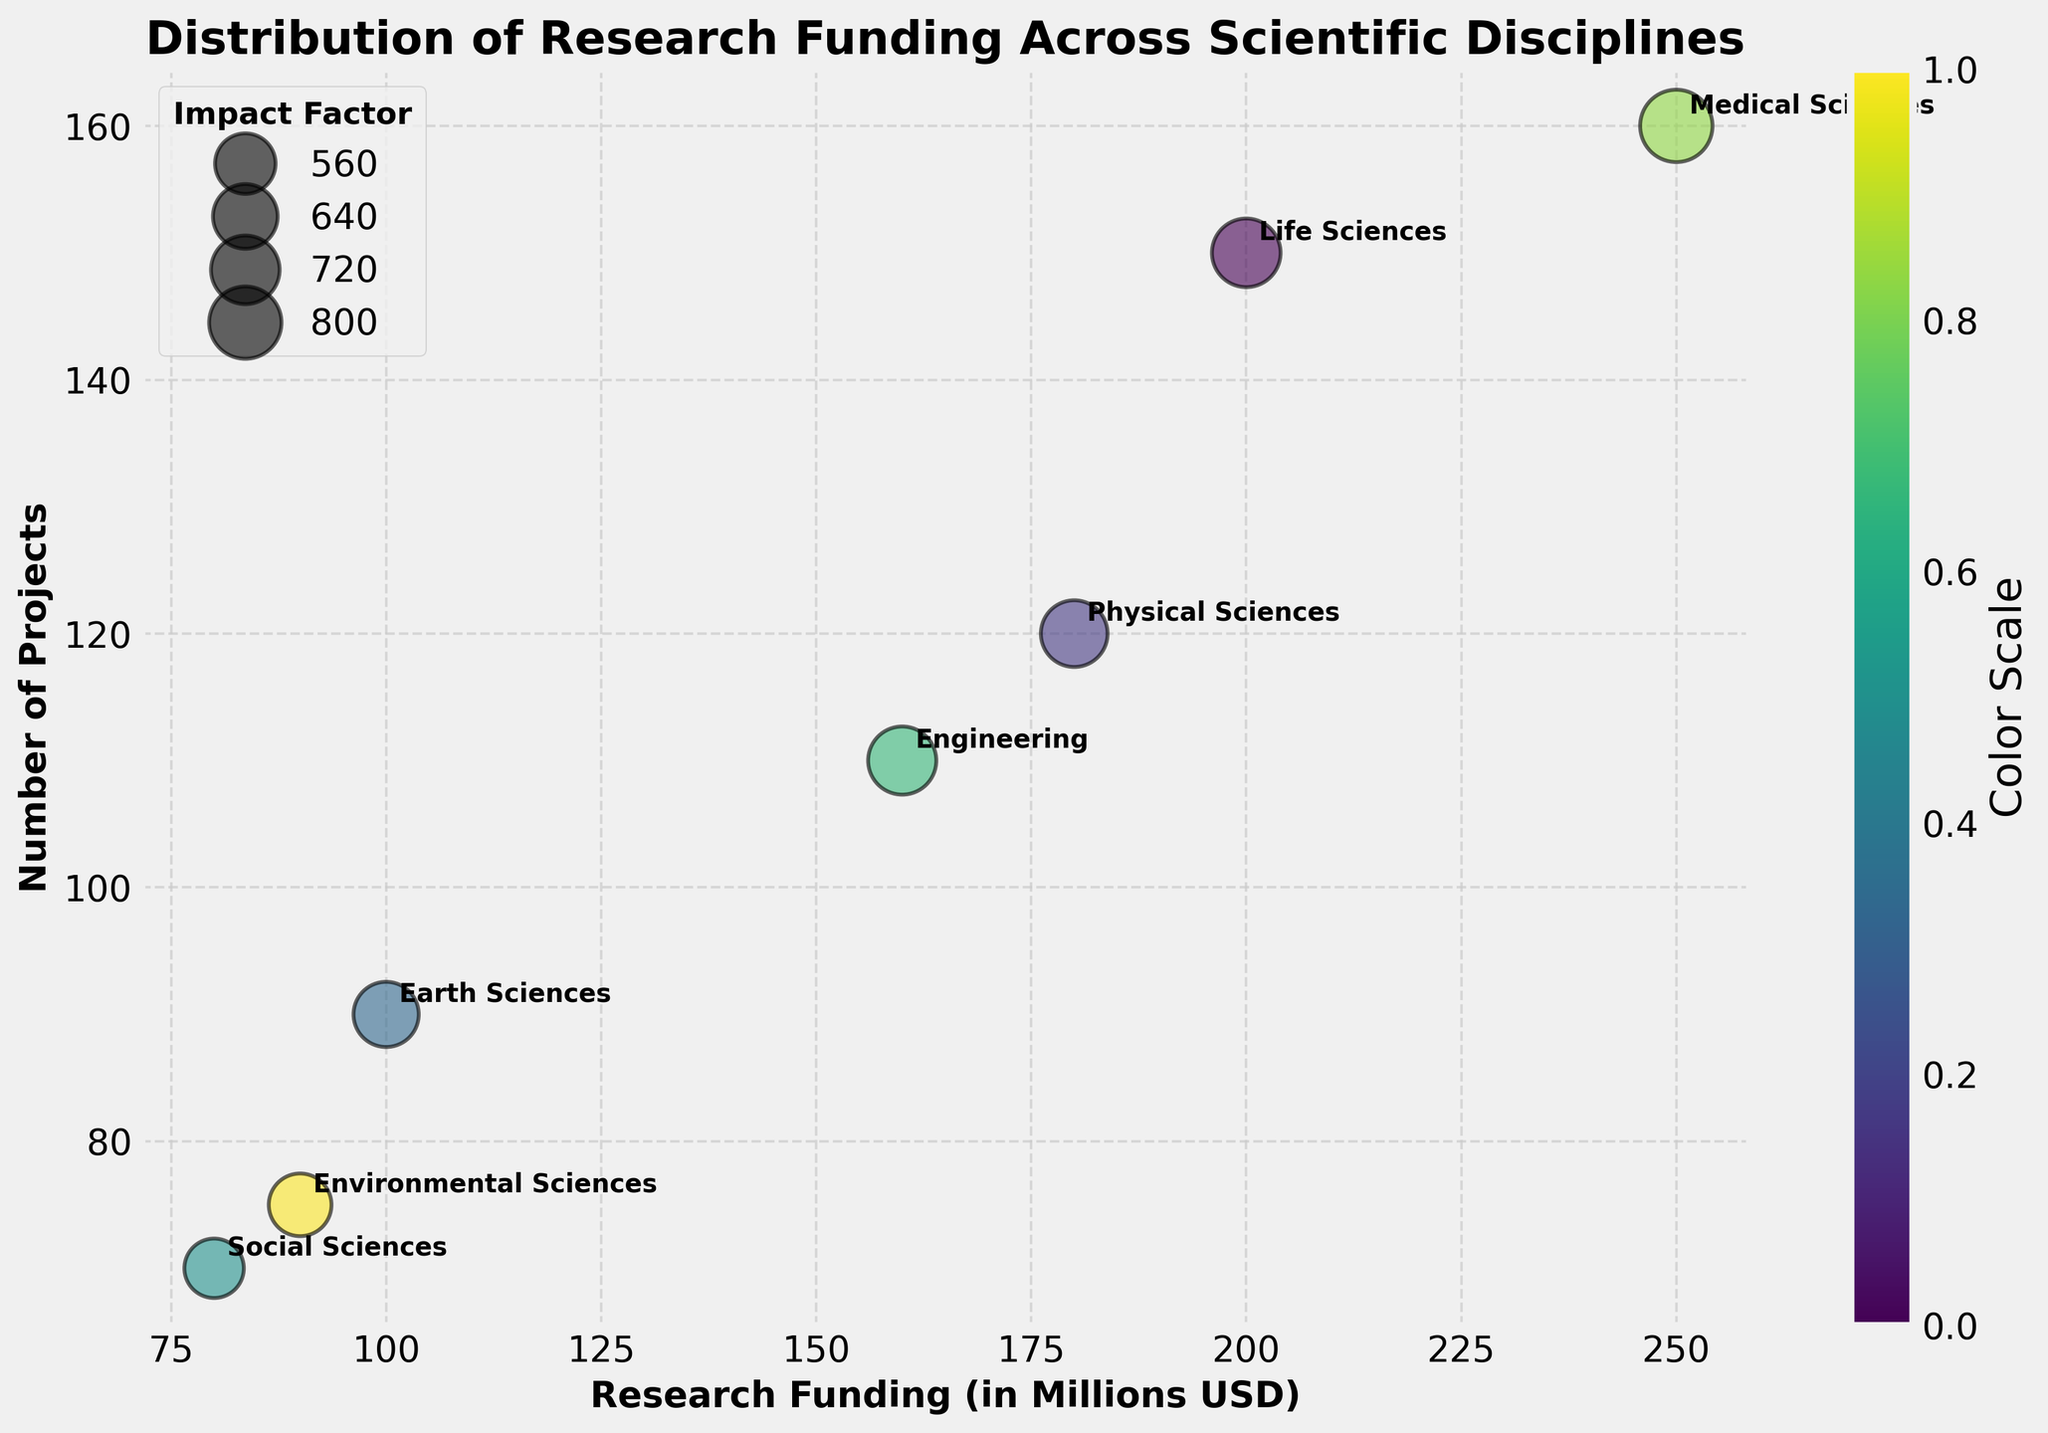What's the title of the figure? The title of the figure is written prominently at the top and provides a summary of what the figure represents.
Answer: Distribution of Research Funding Across Scientific Disciplines What are the labels on the x-axis and y-axis? The x-axis and y-axis labels describe the variables being plotted and are located beside their respective axes.
Answer: Research Funding (in Millions USD) and Number of Projects Which scientific discipline has the highest research funding? By examining the x-axis, the discipline with the furthest point to the right will have the highest research funding.
Answer: Medical Sciences How many scientific disciplines are represented in the chart? Each scientific discipline corresponds to a distinct bubble in the chart. By counting these bubbles, we can find the total number of disciplines.
Answer: 7 Which scientific disciplines have an impact factor greater than or equal to 7? The size of the bubbles represents the impact factor. Larger bubbles correspond to higher impact factors. By checking the sizes, we can determine which ones meet the criteria.
Answer: Life Sciences, Engineering, Medical Sciences Which discipline has the smallest number of projects? By looking at the y-axis and finding the discipline with the lowest position, we determine the discipline with the smallest number of projects.
Answer: Social Sciences How do the research funding and number of projects compare between Life Sciences and Physical Sciences? By referring to the positions of the bubbles for Life Sciences and Physical Sciences on the x-axis (funding) and y-axis (number of projects), we compare their values. Life Sciences has 200 million USD and 150 projects, Physical Sciences has 180 million USD and 120 projects.
Answer: Life Sciences have more funding and more projects What is the difference in research funding between the Medical Sciences and Environmental Sciences? The research funding for Medical Sciences and Environmental Sciences are read from the x-axis, then we calculate the difference between them. Medical Sciences: 250 million USD, Environmental Sciences: 90 million USD. 250 - 90 = 160 million USD.
Answer: 160 million USD Which scientific discipline has the closest number of projects to Engineering? By comparing the y-axis positions, we look for the bubble closest to Engineering's number of projects, which is 110.
Answer: Physical Sciences (120 projects) If you were to look at the color scale, how many distinct colors are present? The color scale represents a gradient that helps to visually distinguish between the bubbles. By observing, we can count the distinct color segments.
Answer: Multiple (color gradient) 